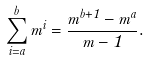Convert formula to latex. <formula><loc_0><loc_0><loc_500><loc_500>\sum _ { i = a } ^ { b } m ^ { i } = \frac { m ^ { b + 1 } - m ^ { a } } { m - 1 } .</formula> 